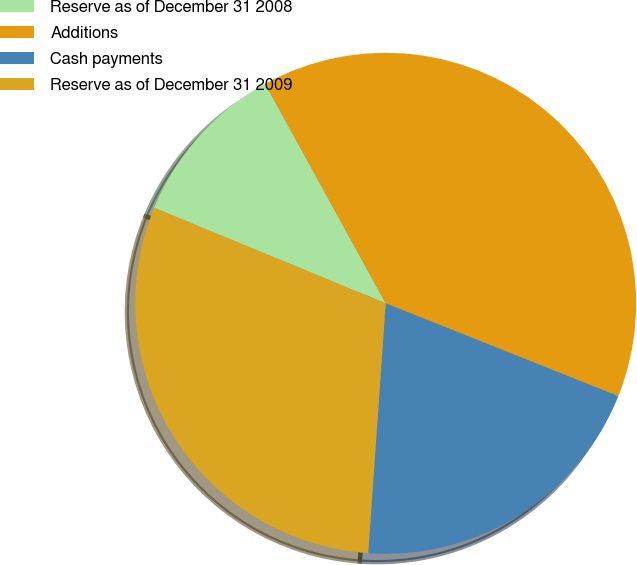Convert chart to OTSL. <chart><loc_0><loc_0><loc_500><loc_500><pie_chart><fcel>Reserve as of December 31 2008<fcel>Additions<fcel>Cash payments<fcel>Reserve as of December 31 2009<nl><fcel>10.78%<fcel>39.03%<fcel>20.07%<fcel>30.11%<nl></chart> 